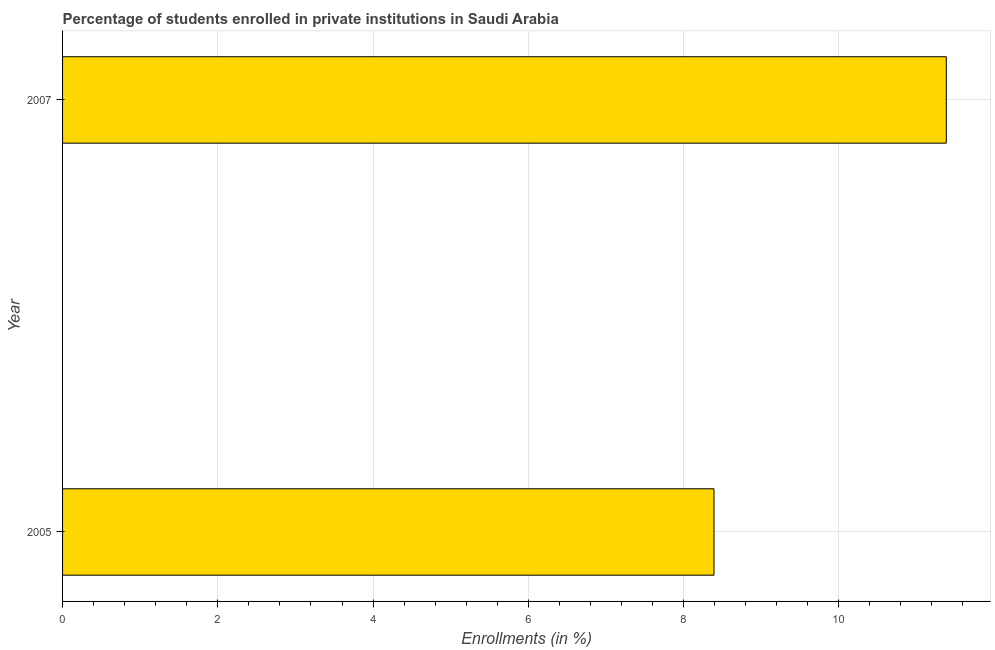Does the graph contain any zero values?
Your answer should be compact. No. What is the title of the graph?
Keep it short and to the point. Percentage of students enrolled in private institutions in Saudi Arabia. What is the label or title of the X-axis?
Offer a very short reply. Enrollments (in %). What is the enrollments in private institutions in 2005?
Provide a succinct answer. 8.39. Across all years, what is the maximum enrollments in private institutions?
Provide a succinct answer. 11.39. Across all years, what is the minimum enrollments in private institutions?
Your response must be concise. 8.39. What is the sum of the enrollments in private institutions?
Offer a terse response. 19.78. What is the difference between the enrollments in private institutions in 2005 and 2007?
Your response must be concise. -2.99. What is the average enrollments in private institutions per year?
Offer a very short reply. 9.89. What is the median enrollments in private institutions?
Your answer should be compact. 9.89. Do a majority of the years between 2007 and 2005 (inclusive) have enrollments in private institutions greater than 2.8 %?
Keep it short and to the point. No. What is the ratio of the enrollments in private institutions in 2005 to that in 2007?
Make the answer very short. 0.74. In how many years, is the enrollments in private institutions greater than the average enrollments in private institutions taken over all years?
Keep it short and to the point. 1. Are all the bars in the graph horizontal?
Your answer should be very brief. Yes. How many years are there in the graph?
Give a very brief answer. 2. Are the values on the major ticks of X-axis written in scientific E-notation?
Your answer should be very brief. No. What is the Enrollments (in %) of 2005?
Give a very brief answer. 8.39. What is the Enrollments (in %) of 2007?
Offer a very short reply. 11.39. What is the difference between the Enrollments (in %) in 2005 and 2007?
Provide a succinct answer. -2.99. What is the ratio of the Enrollments (in %) in 2005 to that in 2007?
Offer a very short reply. 0.74. 